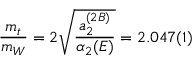Convert formula to latex. <formula><loc_0><loc_0><loc_500><loc_500>\frac { m _ { t } } { m _ { W } } = 2 \sqrt { \frac { a _ { 2 } ^ { ( 2 B ) } } { \alpha _ { 2 } ( E ) } } = 2 . 0 4 7 ( 1 )</formula> 